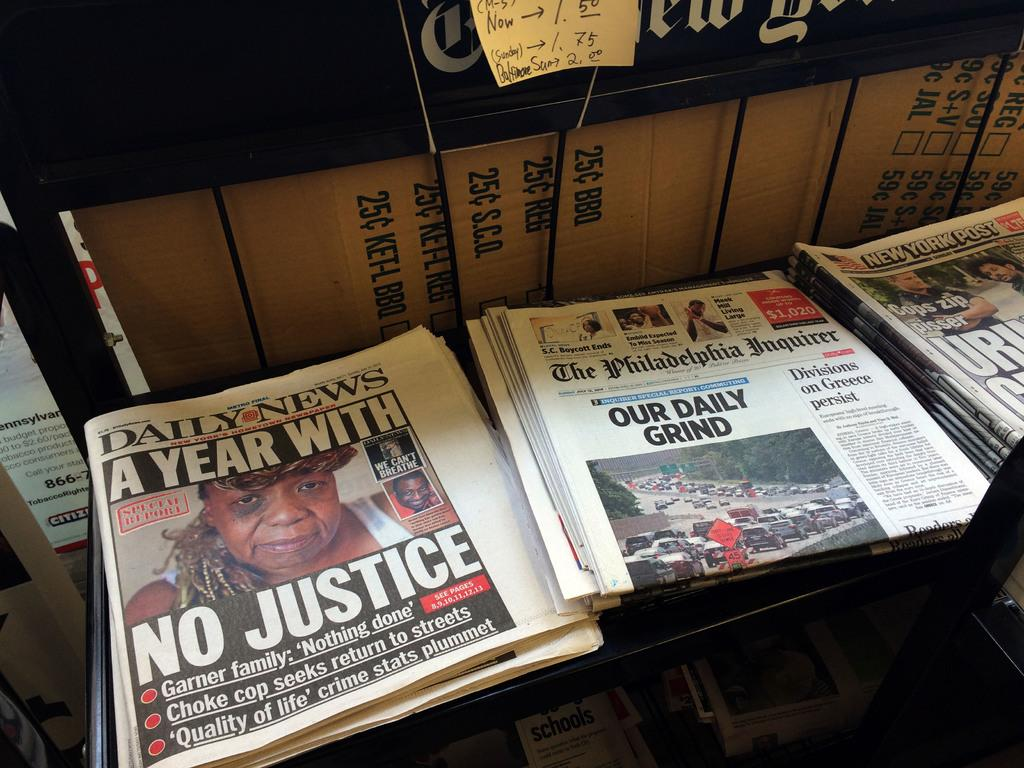<image>
Provide a brief description of the given image. Various newspapers are arranged in stacks, including the Daily News. 